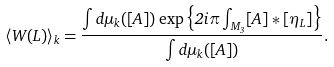Convert formula to latex. <formula><loc_0><loc_0><loc_500><loc_500>\left \langle W ( L ) \right \rangle _ { k } = \frac { \int d \mu _ { k } ( [ A ] ) \exp \left \{ { 2 i \pi \int _ { M _ { 3 } } [ A ] * [ \eta _ { L } ] } \right \} } { \int d \mu _ { k } ( [ A ] ) } .</formula> 